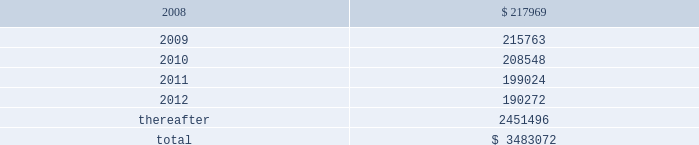American tower corporation and subsidiaries notes to consolidated financial statements 2014 ( continued ) as of december 31 , 2006 , the company held a total of ten interest rate swap agreements to manage exposure to variable rate interest obligations under its amt opco and spectrasite credit facilities and four forward starting interest rate swap agreements to manage exposure to variability in cash flows relating to forecasted interest payments in connection with the securitization which the company designated as cash flow hedges .
The eight american tower swaps had an aggregate notional amount of $ 450.0 million and fixed rates ranging between 4.63% ( 4.63 % ) and 4.88% ( 4.88 % ) and the two spectrasite swaps have an aggregate notional amount of $ 100.0 million and a fixed rate of 4.95% ( 4.95 % ) .
The four forward starting interest rate swap agreements had an aggregate notional amount of $ 900.0 million , fixed rates ranging between 4.73% ( 4.73 % ) and 5.10% ( 5.10 % ) .
As of december 31 , 2006 , the company also held three interest rate swap instruments and one interest rate cap instrument that were acquired in the spectrasite , inc .
Merger in august 2005 and were not designated as cash flow hedges .
The three interest rate swaps , which had a fair value of $ 6.7 million at the date of acquisition , have an aggregate notional amount of $ 300.0 million , a fixed rate of 3.88% ( 3.88 % ) .
The interest rate cap had a notional amount of $ 175.0 million , a fixed rate of 7.0% ( 7.0 % ) , and expired in february 2006 .
As of december 31 , 2006 , other comprehensive income includes unrealized gains on short term available-for-sale securities of $ 10.4 million and unrealized gains related to the interest rate swap agreements in the table above of $ 5.7 million , net of tax .
During the year ended december 31 , 2006 , the company recorded a net unrealized gain of approximately $ 6.5 million ( net of a tax provision of approximately $ 3.5 million ) in other comprehensive loss for the change in fair value of interest rate swaps designated as cash flow hedges and reclassified $ 0.7 million ( net of an income tax benefit of $ 0.2 million ) into results of operations during the year ended december 31 , 2006 .
Commitments and contingencies lease obligations 2014the company leases certain land , office and tower space under operating leases that expire over various terms .
Many of the leases contain renewal options with specified increases in lease payments upon exercise of the renewal option .
Escalation clauses present in operating leases , excluding those tied to cpi or other inflation-based indices , are recognized on a straight-line basis over the non-cancelable term of the lease .
( see note 1. ) future minimum rental payments under non-cancelable operating leases include payments for certain renewal periods at the company 2019s option because failure to renew could result in a loss of the applicable tower site and related revenues from tenant leases , thereby making it reasonably assured that the company will renew the lease .
Such payments in effect at december 31 , 2007 are as follows ( in thousands ) : year ending december 31 .
Aggregate rent expense ( including the effect of straight-line rent expense ) under operating leases for the years ended december 31 , 2007 , 2006 and 2005 approximated $ 246.4 million , $ 237.0 million and $ 168.7 million , respectively. .
In 2006 what was the approximate tax rate on unrecognized tax gain the in fair value of interest rate swaps designated as cash flow hedges? 
Computations: (3.5 / (6.5 + 3.5))
Answer: 0.35. 